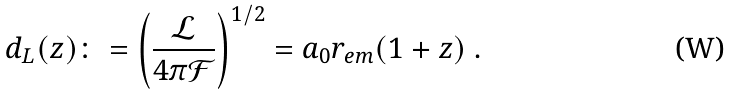<formula> <loc_0><loc_0><loc_500><loc_500>d _ { L } ( z ) \colon = \left ( \frac { \mathcal { L } } { 4 \pi \mathcal { F } } \right ) ^ { 1 / 2 } = a _ { 0 } r _ { e m } ( 1 + z ) \ .</formula> 